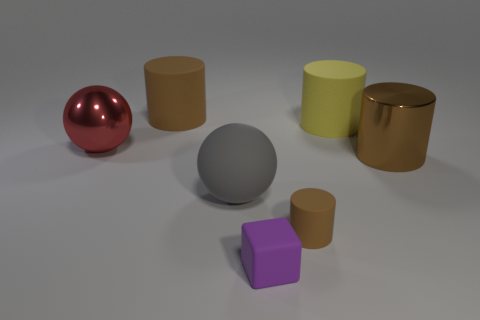What number of big yellow cylinders are the same material as the small purple thing?
Your answer should be very brief. 1. There is a brown shiny cylinder; does it have the same size as the brown rubber cylinder that is behind the yellow matte thing?
Make the answer very short. Yes. There is a small thing that is the same color as the large metal cylinder; what material is it?
Offer a terse response. Rubber. How big is the rubber cylinder that is in front of the shiny object that is to the right of the rubber cylinder in front of the metallic sphere?
Your answer should be very brief. Small. Are there more tiny rubber objects that are right of the purple cube than cylinders behind the large yellow cylinder?
Keep it short and to the point. No. How many big brown cylinders are on the right side of the large matte thing on the right side of the tiny brown rubber object?
Ensure brevity in your answer.  1. Is there a large ball that has the same color as the matte block?
Your answer should be compact. No. Does the red shiny ball have the same size as the gray thing?
Keep it short and to the point. Yes. Does the shiny sphere have the same color as the large rubber sphere?
Give a very brief answer. No. What is the material of the big brown cylinder behind the large metal thing that is to the left of the large gray ball?
Offer a terse response. Rubber. 